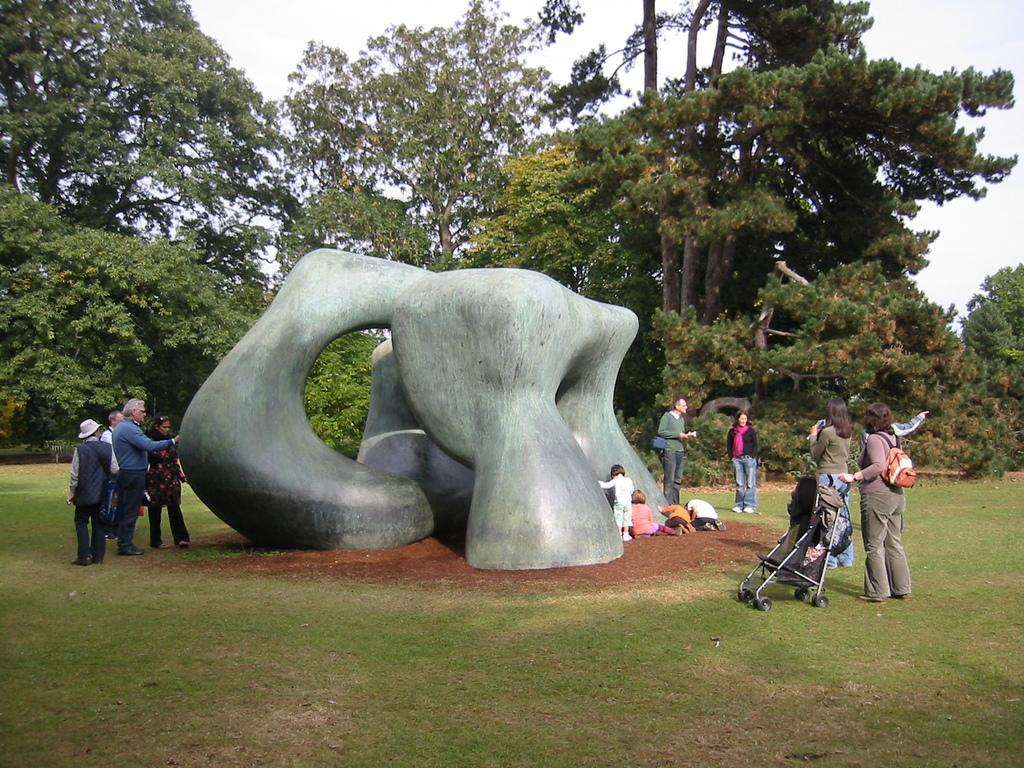What is the main subject in the center of the image? There is a sculpture in the center of the image. What can be seen on the right side of the image? There is a trolley on the right side of the image. What is visible in the background of the image? People, trees, and the sky are visible in the background of the image. What type of ground is present at the bottom of the image? There is grass at the bottom of the image. What arithmetic problem is being solved by the person in the image? There is no person present in the image, so no arithmetic problem can be observed. 